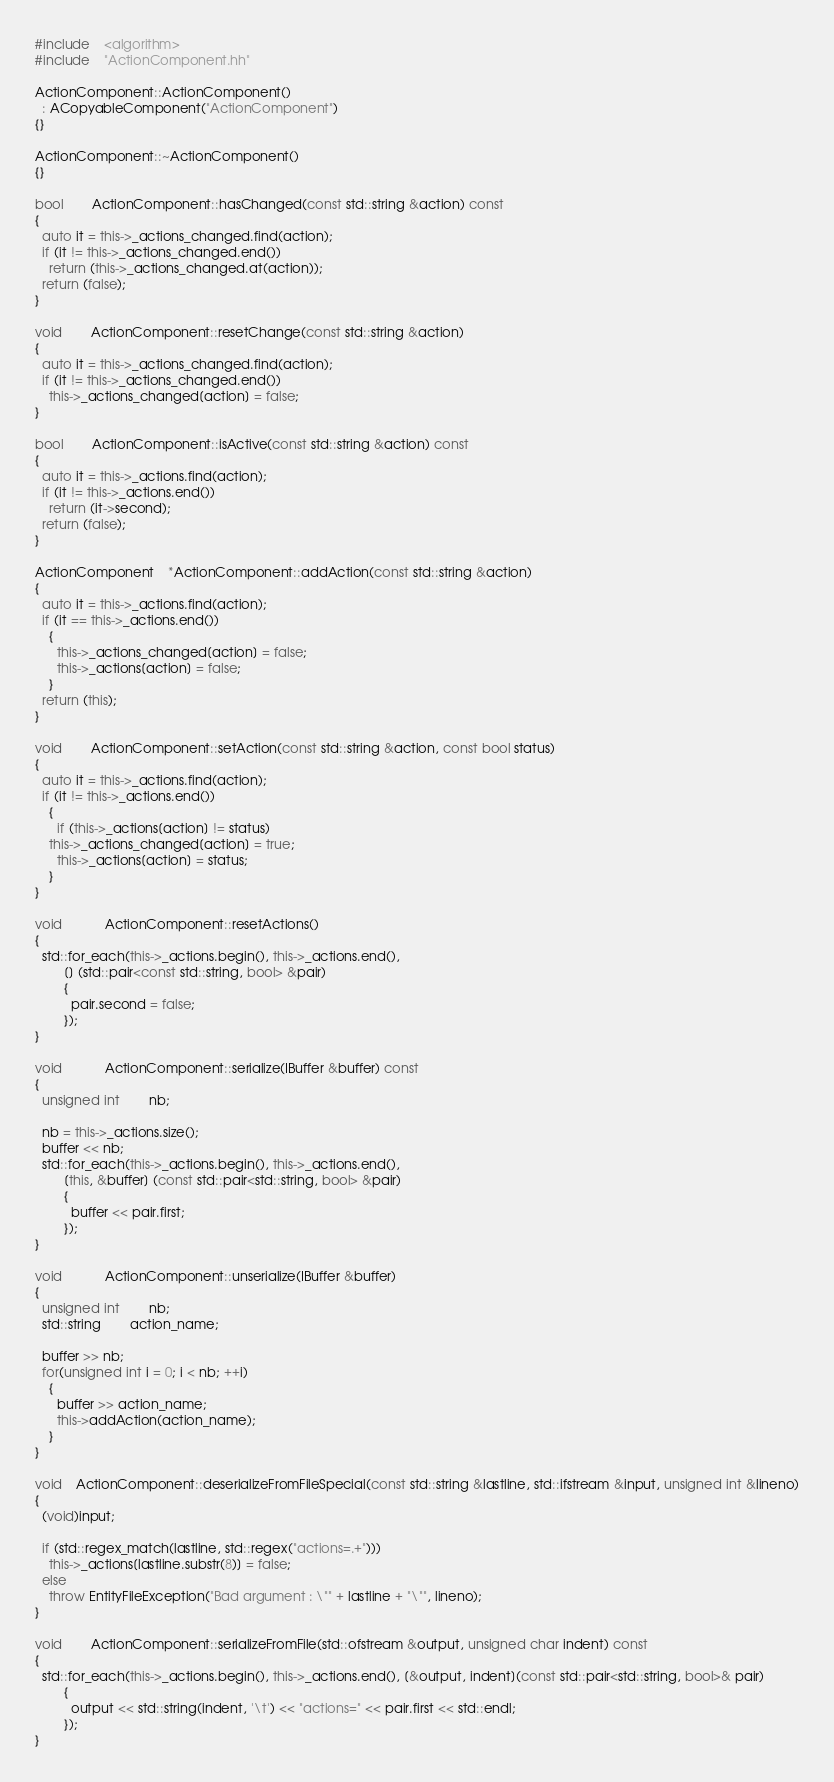<code> <loc_0><loc_0><loc_500><loc_500><_C++_>#include	<algorithm>
#include	"ActionComponent.hh"

ActionComponent::ActionComponent()
  : ACopyableComponent("ActionComponent")
{}

ActionComponent::~ActionComponent()
{}

bool		ActionComponent::hasChanged(const std::string &action) const
{
  auto it = this->_actions_changed.find(action);
  if (it != this->_actions_changed.end())
    return (this->_actions_changed.at(action));
  return (false);
}

void		ActionComponent::resetChange(const std::string &action)
{
  auto it = this->_actions_changed.find(action);
  if (it != this->_actions_changed.end())
    this->_actions_changed[action] = false;
}

bool		ActionComponent::isActive(const std::string &action) const
{
  auto it = this->_actions.find(action);
  if (it != this->_actions.end())
    return (it->second);
  return (false);
}

ActionComponent	*ActionComponent::addAction(const std::string &action)
{
  auto it = this->_actions.find(action);
  if (it == this->_actions.end())
    {
      this->_actions_changed[action] = false;
      this->_actions[action] = false;
    }
  return (this);
}

void		ActionComponent::setAction(const std::string &action, const bool status)
{
  auto it = this->_actions.find(action);
  if (it != this->_actions.end())
    {
      if (this->_actions[action] != status)
	this->_actions_changed[action] = true;
      this->_actions[action] = status;
    }
}

void			ActionComponent::resetActions()
{
  std::for_each(this->_actions.begin(), this->_actions.end(),
		[] (std::pair<const std::string, bool> &pair)
		{
		  pair.second = false;
		});
}

void			ActionComponent::serialize(IBuffer &buffer) const
{
  unsigned int		nb;

  nb = this->_actions.size();
  buffer << nb;
  std::for_each(this->_actions.begin(), this->_actions.end(),
		[this, &buffer] (const std::pair<std::string, bool> &pair)
		{
		  buffer << pair.first;
		});
}

void			ActionComponent::unserialize(IBuffer &buffer)
{
  unsigned int		nb;
  std::string		action_name;

  buffer >> nb;
  for(unsigned int i = 0; i < nb; ++i)
    {
      buffer >> action_name;
      this->addAction(action_name);
    }
}

void	ActionComponent::deserializeFromFileSpecial(const std::string &lastline, std::ifstream &input, unsigned int &lineno)
{
  (void)input;

  if (std::regex_match(lastline, std::regex("actions=.+")))
    this->_actions[lastline.substr(8)] = false;
  else
    throw EntityFileException("Bad argument : \"" + lastline + "\"", lineno);
}

void		ActionComponent::serializeFromFile(std::ofstream &output, unsigned char indent) const
{
  std::for_each(this->_actions.begin(), this->_actions.end(), [&output, indent](const std::pair<std::string, bool>& pair)
		{
		  output << std::string(indent, '\t') << "actions=" << pair.first << std::endl;
		});
}
</code> 